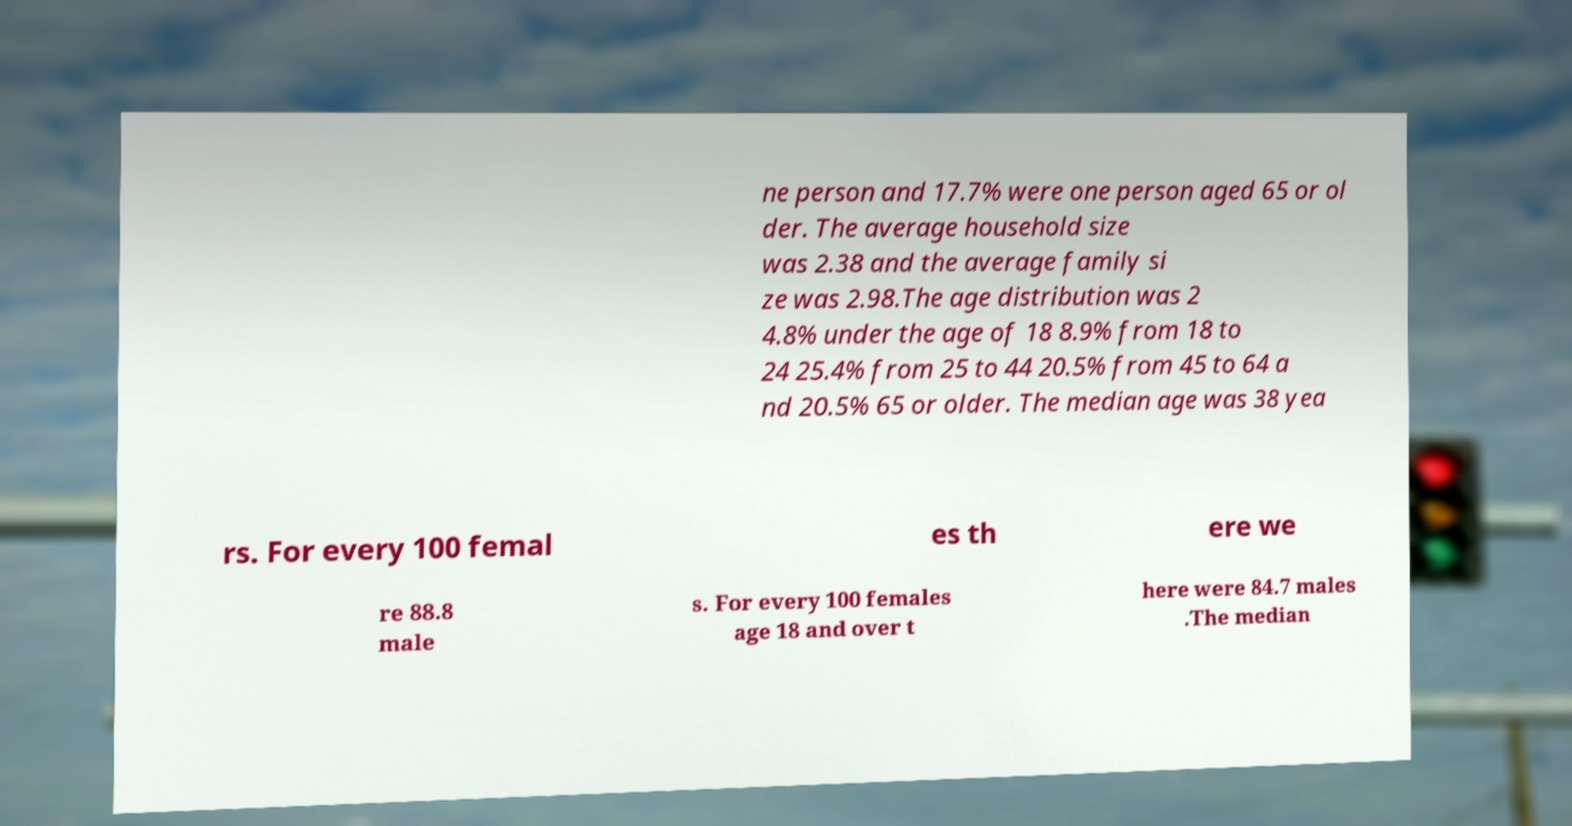Please identify and transcribe the text found in this image. ne person and 17.7% were one person aged 65 or ol der. The average household size was 2.38 and the average family si ze was 2.98.The age distribution was 2 4.8% under the age of 18 8.9% from 18 to 24 25.4% from 25 to 44 20.5% from 45 to 64 a nd 20.5% 65 or older. The median age was 38 yea rs. For every 100 femal es th ere we re 88.8 male s. For every 100 females age 18 and over t here were 84.7 males .The median 